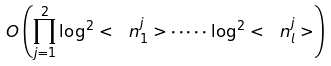<formula> <loc_0><loc_0><loc_500><loc_500>O \left ( \prod _ { j = 1 } ^ { 2 } \log ^ { 2 } < \ n _ { 1 } ^ { j } > \cdot \dots \cdot \log ^ { 2 } < \ n _ { l } ^ { j } > \right )</formula> 